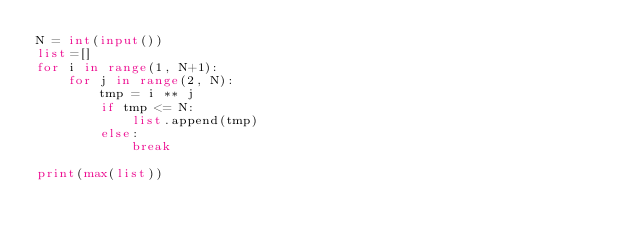Convert code to text. <code><loc_0><loc_0><loc_500><loc_500><_Python_>N = int(input())
list=[]
for i in range(1, N+1):
    for j in range(2, N):
        tmp = i ** j
        if tmp <= N:
            list.append(tmp)
        else:
            break

print(max(list))

</code> 